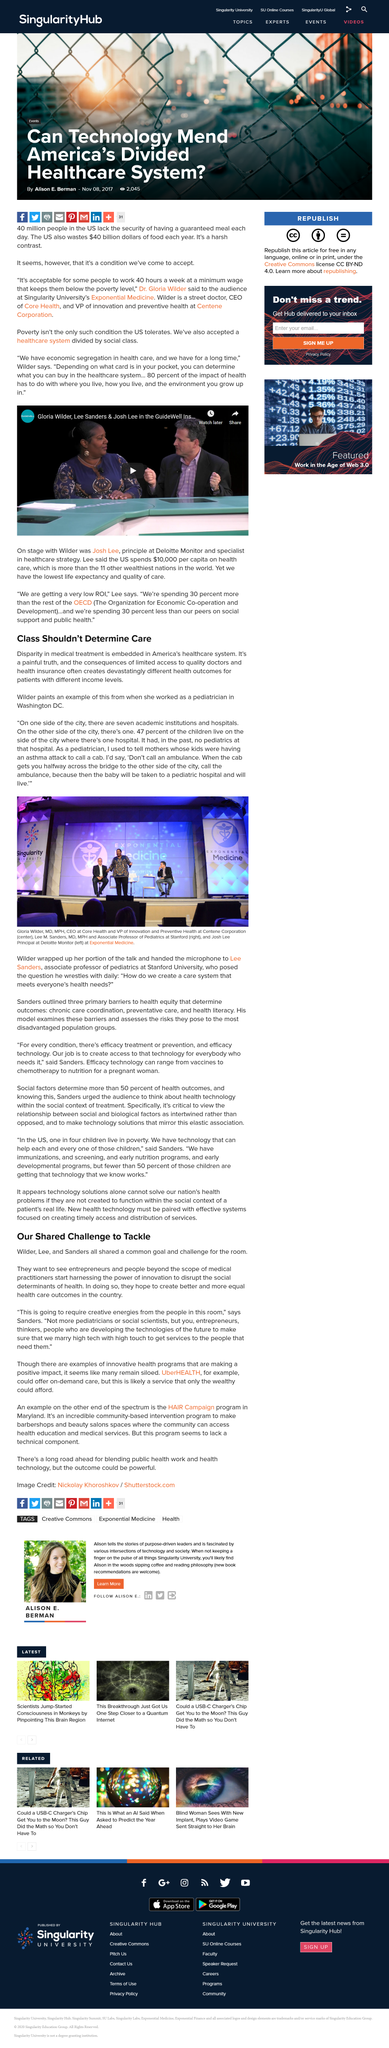Mention a couple of crucial points in this snapshot. Research demonstrates that patients from different income levels may experience varying health outcomes, with those from low-income backgrounds frequently facing more significant health challenges than their higher-income counterparts. Dr. Gloria Wilder is a street doctor, CEO of Core Health, and VP of innovation and preventive health at Centene Corporation. The United States spends approximately $40 billion dollars annually on food waste. We, Wilder, Lee and Sanders, hope to achieve better and more equitable healthcare outcomes in our country through this common goal and challenge. Wilder painted an example of the disparities in medical treatment, which illustrates the unfair and unequal access to healthcare among different groups. 